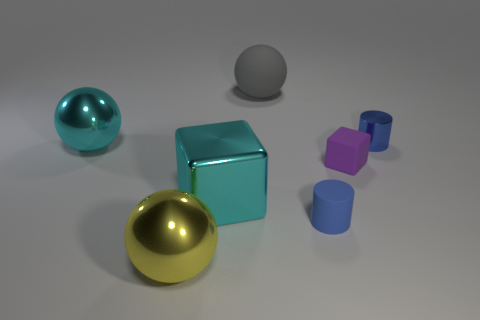Subtract all red balls. Subtract all green blocks. How many balls are left? 3 Add 3 cyan metallic cylinders. How many objects exist? 10 Subtract all cubes. How many objects are left? 5 Subtract 1 gray balls. How many objects are left? 6 Subtract all gray rubber objects. Subtract all small purple things. How many objects are left? 5 Add 5 small purple rubber blocks. How many small purple rubber blocks are left? 6 Add 3 large red objects. How many large red objects exist? 3 